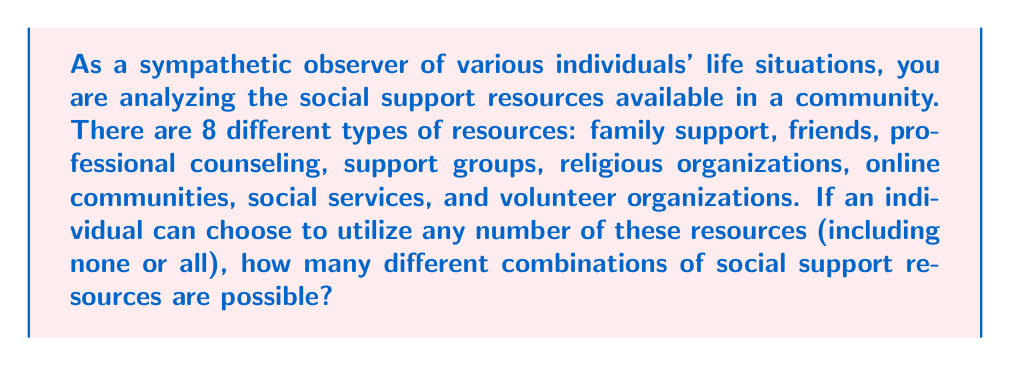Help me with this question. To solve this problem, we need to understand that this is a combination problem where order doesn't matter (e.g., choosing family support and friends is the same as choosing friends and family support). Each resource can either be chosen or not chosen, which gives us two options for each resource.

This scenario is a perfect example of the power set concept in combinatorics. The power set of a set is the set of all possible subsets, including the empty set (choosing no resources) and the set itself (choosing all resources).

For a set with $n$ elements, the number of subsets in its power set is given by $2^n$. This is because for each element, we have two choices: include it or not include it.

In this case, we have 8 different types of resources. So, $n = 8$.

Therefore, the number of possible combinations is:

$$ 2^8 = 2 \times 2 \times 2 \times 2 \times 2 \times 2 \times 2 \times 2 = 256 $$

We can break this down further:
- 1 way to choose no resources
- 8 ways to choose exactly 1 resource
- 28 ways to choose exactly 2 resources
- 56 ways to choose exactly 3 resources
- 70 ways to choose exactly 4 resources
- 56 ways to choose exactly 5 resources
- 28 ways to choose exactly 6 resources
- 8 ways to choose exactly 7 resources
- 1 way to choose all 8 resources

$1 + 8 + 28 + 56 + 70 + 56 + 28 + 8 + 1 = 256$

This calculation demonstrates all the possible ways an individual could combine these social support resources, from utilizing none of them to using all of them, and every combination in between.
Answer: $256$ combinations 